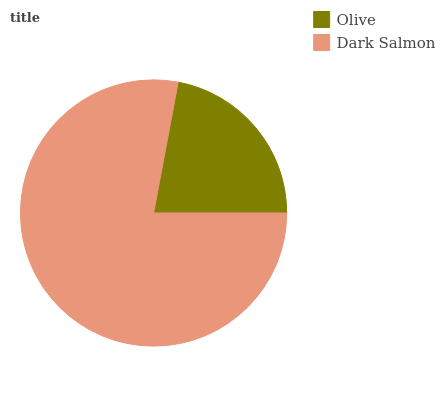Is Olive the minimum?
Answer yes or no. Yes. Is Dark Salmon the maximum?
Answer yes or no. Yes. Is Dark Salmon the minimum?
Answer yes or no. No. Is Dark Salmon greater than Olive?
Answer yes or no. Yes. Is Olive less than Dark Salmon?
Answer yes or no. Yes. Is Olive greater than Dark Salmon?
Answer yes or no. No. Is Dark Salmon less than Olive?
Answer yes or no. No. Is Dark Salmon the high median?
Answer yes or no. Yes. Is Olive the low median?
Answer yes or no. Yes. Is Olive the high median?
Answer yes or no. No. Is Dark Salmon the low median?
Answer yes or no. No. 